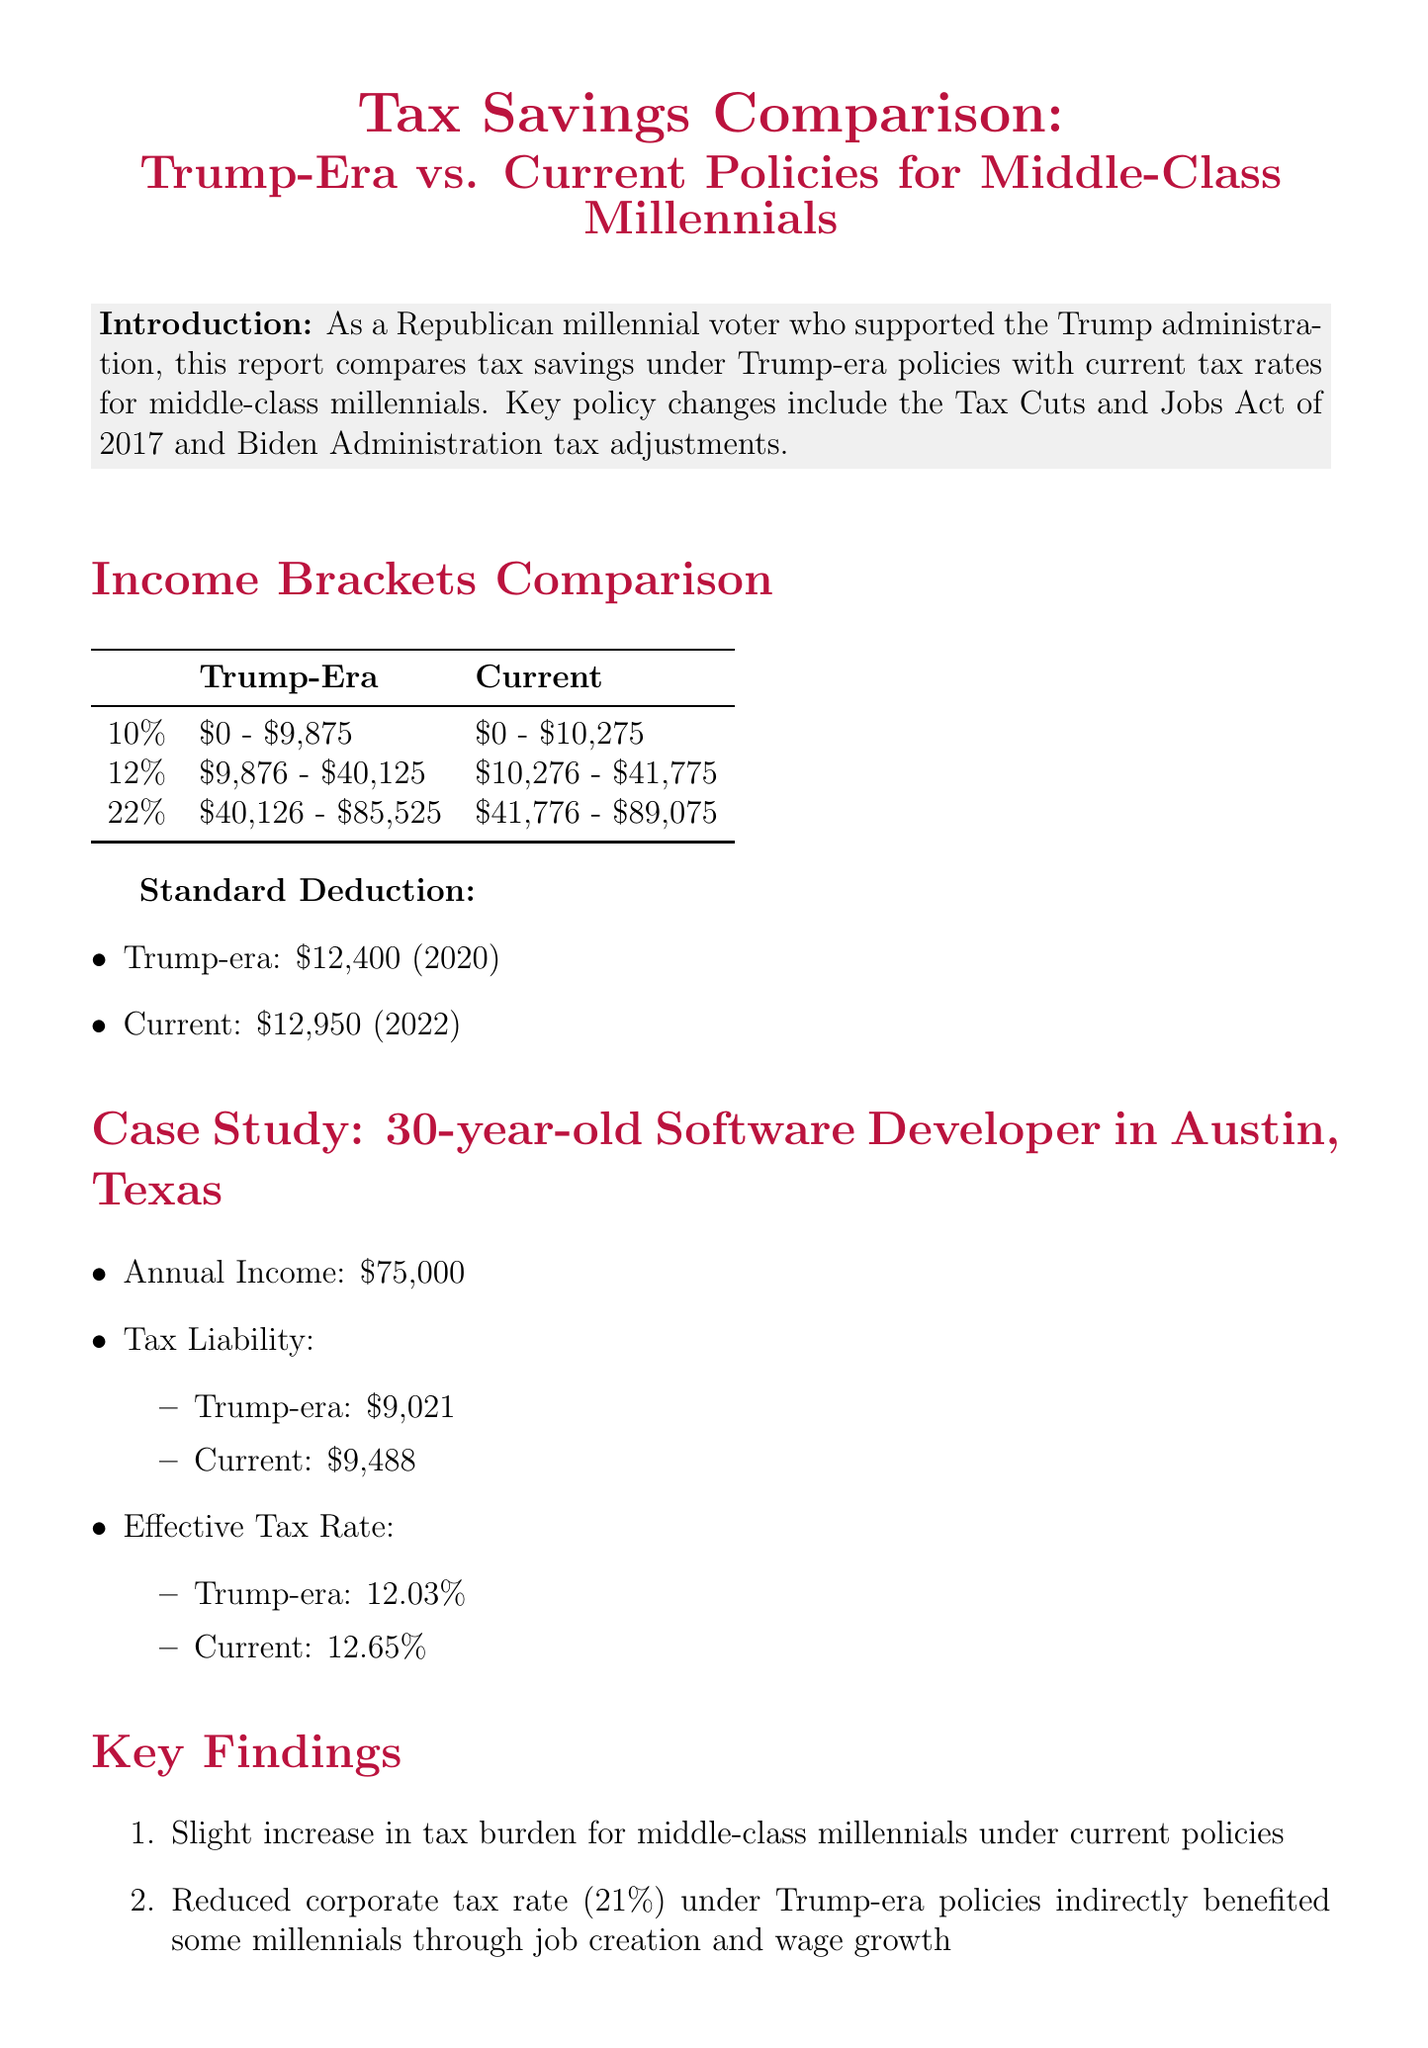What was the standard deduction in the Trump era? The standard deduction in the Trump era was $12,400 for the year 2020.
Answer: $12,400 What is the effective tax rate for a 30-year-old software developer under current policies? The effective tax rate for this profile under current policies is 12.65%.
Answer: 12.65% What income range is taxed at 22% under Trump-era policies? The income range taxed at 22% under Trump-era policies is $40,126 - $85,525.
Answer: $40,126 - $85,525 How much was the annual tax liability for the case study under Trump-era policies? The annual tax liability for the case study under Trump-era policies was $9,021.
Answer: $9,021 What is a key finding regarding middle-class millennials under current policies? A key finding is that there is a slight increase in tax burden for middle-class millennials under current policies.
Answer: Increase in tax burden What major tax legislation is referenced for the Trump era? The major tax legislation referenced for the Trump era is the Tax Cuts and Jobs Act of 2017.
Answer: Tax Cuts and Jobs Act of 2017 What tax rate applies to income between $10,276 and $41,775 under current policies? The tax rate that applies to this income range under current policies is 12%.
Answer: 12% What was the tax liability under current policies for the case study? The tax liability under current policies for the case study was $9,488.
Answer: $9,488 What is the main difference in tax savings between Trump-era policies and current rates for middle-class millennials? The main difference is that Trump-era policies generally provided more tax savings compared to current rates.
Answer: More tax savings 